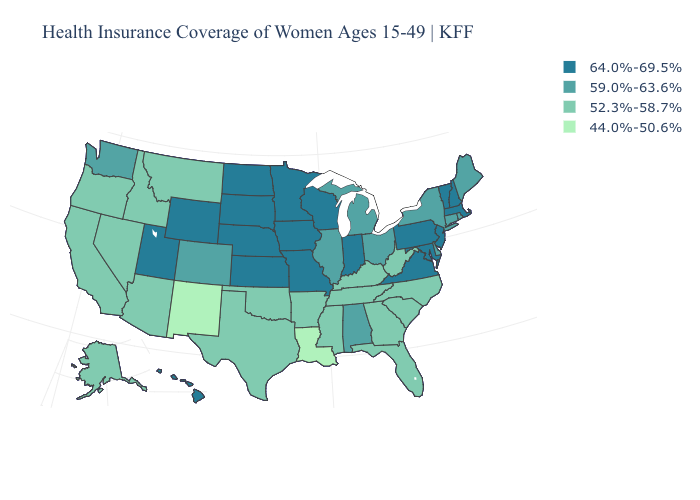Does the first symbol in the legend represent the smallest category?
Keep it brief. No. What is the value of Nevada?
Answer briefly. 52.3%-58.7%. Name the states that have a value in the range 64.0%-69.5%?
Be succinct. Hawaii, Indiana, Iowa, Kansas, Maryland, Massachusetts, Minnesota, Missouri, Nebraska, New Hampshire, New Jersey, North Dakota, Pennsylvania, South Dakota, Utah, Vermont, Virginia, Wisconsin, Wyoming. Among the states that border Delaware , which have the highest value?
Short answer required. Maryland, New Jersey, Pennsylvania. Name the states that have a value in the range 52.3%-58.7%?
Write a very short answer. Alaska, Arizona, Arkansas, California, Florida, Georgia, Idaho, Kentucky, Mississippi, Montana, Nevada, North Carolina, Oklahoma, Oregon, South Carolina, Tennessee, Texas, West Virginia. Does West Virginia have the highest value in the South?
Be succinct. No. Which states have the lowest value in the USA?
Be succinct. Louisiana, New Mexico. Does Ohio have the highest value in the MidWest?
Concise answer only. No. Does the first symbol in the legend represent the smallest category?
Write a very short answer. No. Which states have the lowest value in the Northeast?
Be succinct. Connecticut, Maine, New York, Rhode Island. What is the value of Missouri?
Give a very brief answer. 64.0%-69.5%. What is the value of Rhode Island?
Concise answer only. 59.0%-63.6%. Does Kansas have a higher value than California?
Concise answer only. Yes. Among the states that border Utah , does New Mexico have the lowest value?
Be succinct. Yes. Name the states that have a value in the range 64.0%-69.5%?
Concise answer only. Hawaii, Indiana, Iowa, Kansas, Maryland, Massachusetts, Minnesota, Missouri, Nebraska, New Hampshire, New Jersey, North Dakota, Pennsylvania, South Dakota, Utah, Vermont, Virginia, Wisconsin, Wyoming. 